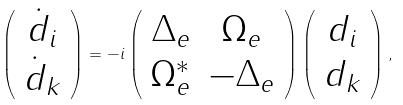<formula> <loc_0><loc_0><loc_500><loc_500>\left ( \begin{array} { c } \dot { d } _ { i } \\ \dot { d } _ { k } \end{array} \right ) = - i \left ( \begin{array} { c c } \Delta _ { e } & \Omega _ { e } \\ \Omega _ { e } ^ { * } & - \Delta _ { e } \end{array} \right ) \left ( \begin{array} { c } d _ { i } \\ d _ { k } \end{array} \right ) ,</formula> 